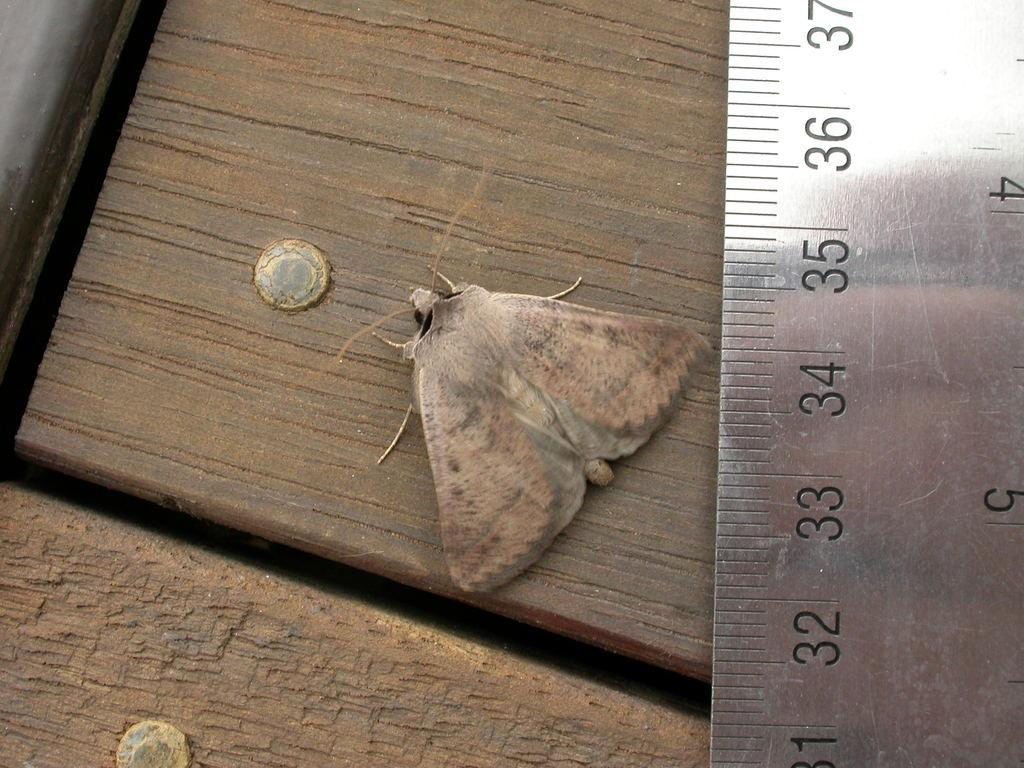<image>
Write a terse but informative summary of the picture. A silver ruler showing the the moth at approximately the 34 inch mark. 